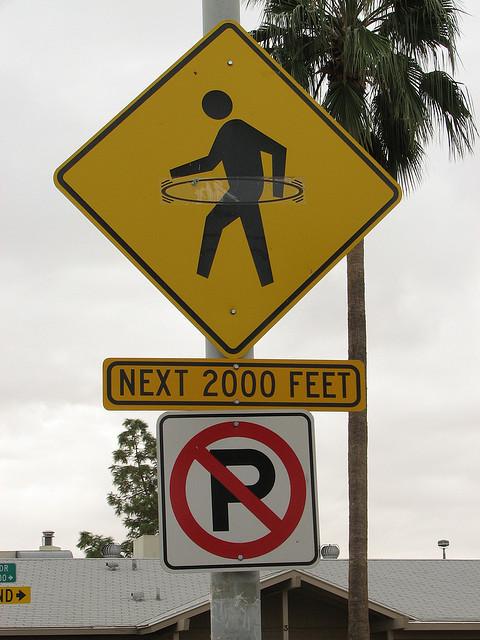What isn't allowed, according to this sign?
Short answer required. Parking. What letters do you see?
Concise answer only. Next feet p. Why are the sign's different color's?
Answer briefly. Different meanings. What sign is this?
Short answer required. No parking. What color is the sign?
Keep it brief. Yellow. What does the sign with the red circle mean?
Concise answer only. No parking. How many signs are there?
Give a very brief answer. 3. How many signs are on the pole?
Keep it brief. 3. During what times is parking not allowed in front of this sign?
Give a very brief answer. Never. How many signs are on the post?
Quick response, please. 3. What is hanging from the street sign?
Short answer required. Sticker. What drawing is on the sign?
Write a very short answer. Surfboard. What is stretched across the bottom sign?
Answer briefly. Sticker. What is above the yellow sign?
Give a very brief answer. Tree. Is the sun shining?
Answer briefly. No. What color are the letters?
Short answer required. Black. 